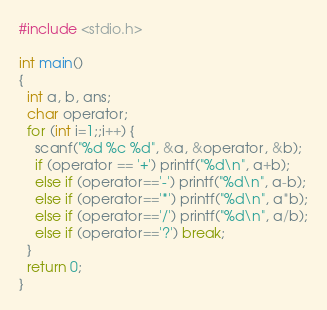Convert code to text. <code><loc_0><loc_0><loc_500><loc_500><_C_>#include <stdio.h>

int main()
{
  int a, b, ans;
  char operator;
  for (int i=1;;i++) {
    scanf("%d %c %d", &a, &operator, &b);
    if (operator == '+') printf("%d\n", a+b);
    else if (operator=='-') printf("%d\n", a-b);
    else if (operator=='*') printf("%d\n", a*b);
    else if (operator=='/') printf("%d\n", a/b);
    else if (operator=='?') break;
  }
  return 0;
}
</code> 